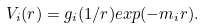<formula> <loc_0><loc_0><loc_500><loc_500>V _ { i } ( r ) = g _ { i } ( 1 / r ) e x p ( - m _ { i } r ) .</formula> 